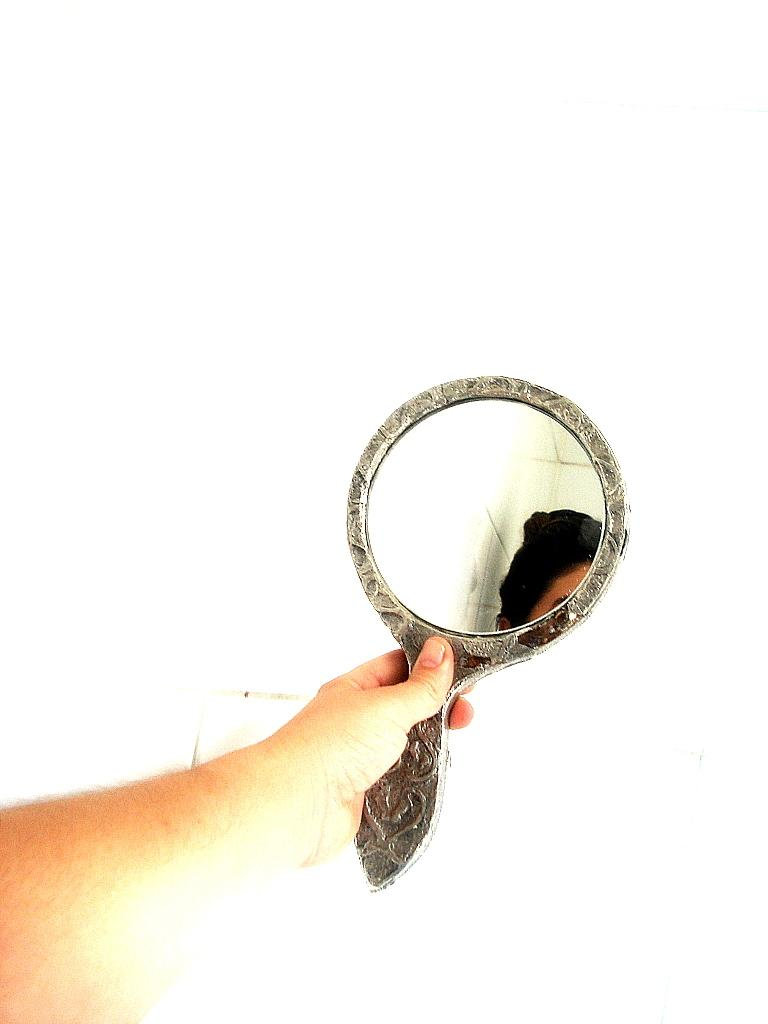What can be seen in the image that belongs to a person? There is a hand of a person in the image. What is the hand holding? The hand is holding a hand mirror. What color is the background of the image? The background of the image is white in color. What type of mint is being served at the feast in the image? There is no feast or mint present in the image; it only features a hand holding a hand mirror against a white background. 